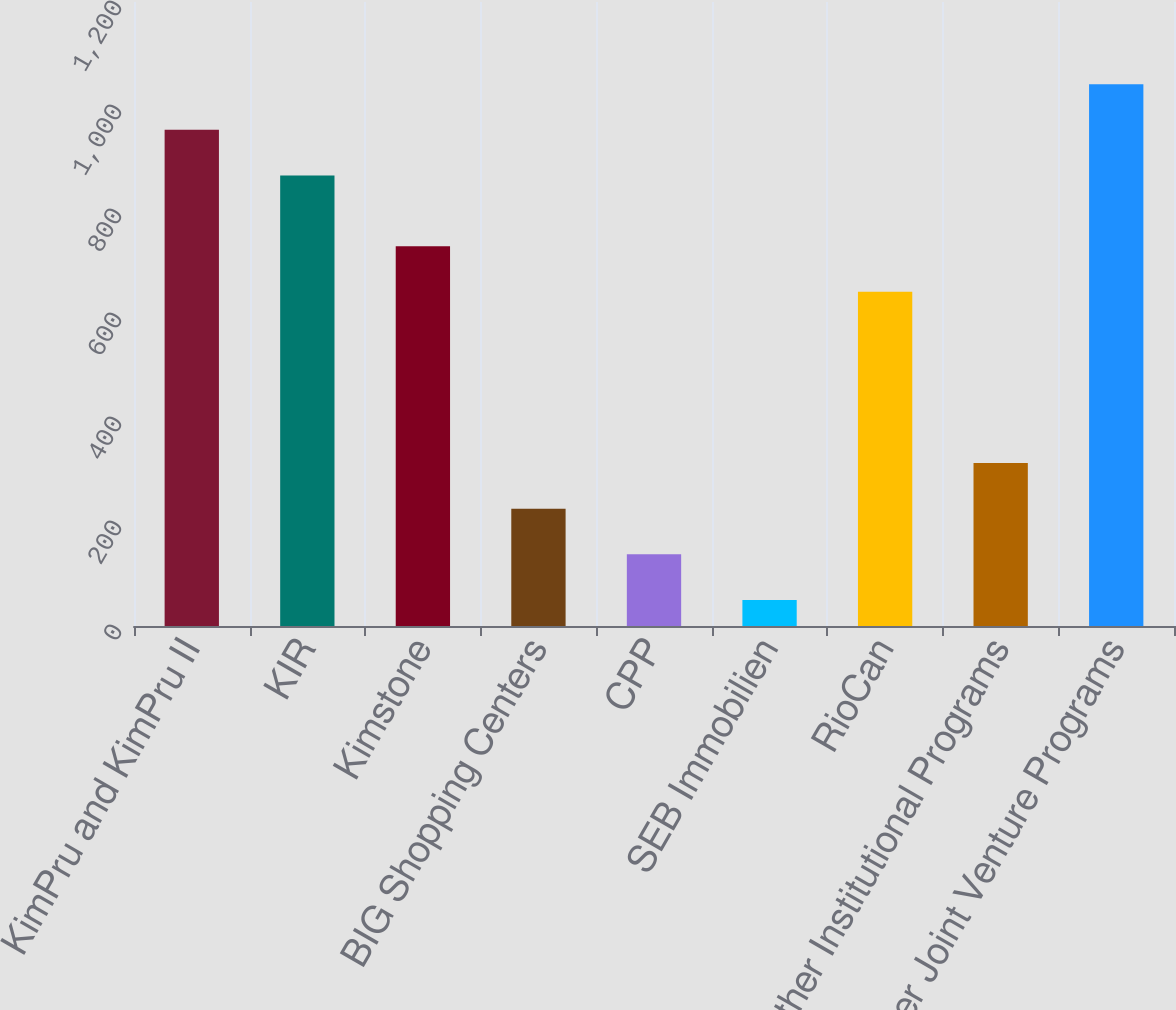Convert chart to OTSL. <chart><loc_0><loc_0><loc_500><loc_500><bar_chart><fcel>KimPru and KimPru II<fcel>KIR<fcel>Kimstone<fcel>BIG Shopping Centers<fcel>CPP<fcel>SEB Immobilien<fcel>RioCan<fcel>Other Institutional Programs<fcel>Other Joint Venture Programs<nl><fcel>954.13<fcel>866.4<fcel>730.33<fcel>225.66<fcel>137.93<fcel>50.2<fcel>642.6<fcel>313.39<fcel>1041.86<nl></chart> 